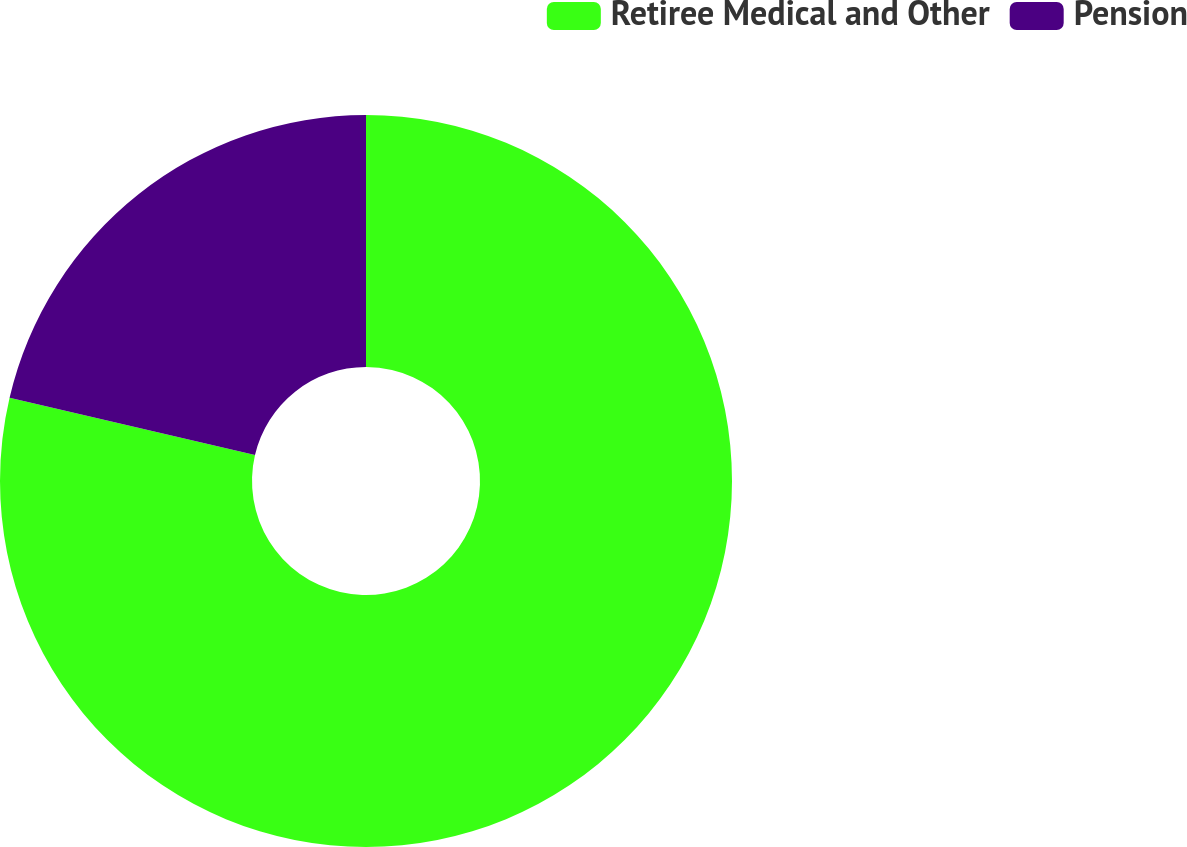Convert chart. <chart><loc_0><loc_0><loc_500><loc_500><pie_chart><fcel>Retiree Medical and Other<fcel>Pension<nl><fcel>78.65%<fcel>21.35%<nl></chart> 